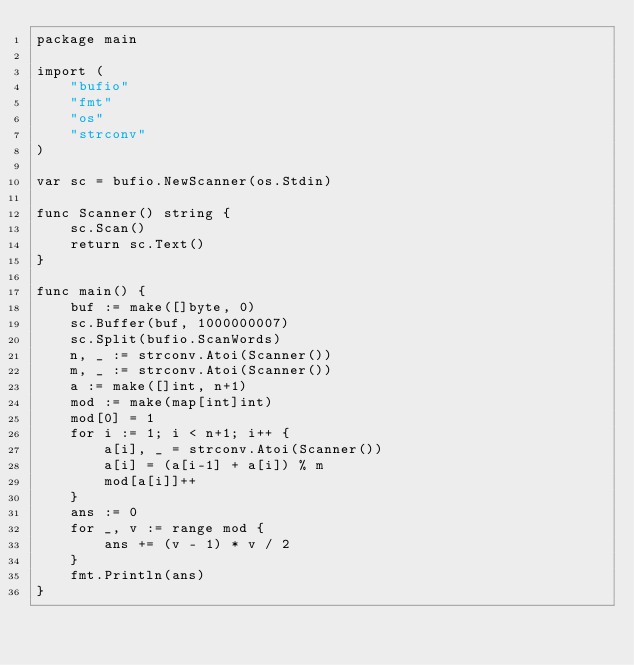<code> <loc_0><loc_0><loc_500><loc_500><_Go_>package main

import (
	"bufio"
	"fmt"
	"os"
	"strconv"
)

var sc = bufio.NewScanner(os.Stdin)

func Scanner() string {
	sc.Scan()
	return sc.Text()
}

func main() {
	buf := make([]byte, 0)
	sc.Buffer(buf, 1000000007)
	sc.Split(bufio.ScanWords)
	n, _ := strconv.Atoi(Scanner())
	m, _ := strconv.Atoi(Scanner())
	a := make([]int, n+1)
	mod := make(map[int]int)
	mod[0] = 1
	for i := 1; i < n+1; i++ {
		a[i], _ = strconv.Atoi(Scanner())
		a[i] = (a[i-1] + a[i]) % m
		mod[a[i]]++
	}
	ans := 0
	for _, v := range mod {
		ans += (v - 1) * v / 2
	}
	fmt.Println(ans)
}
</code> 